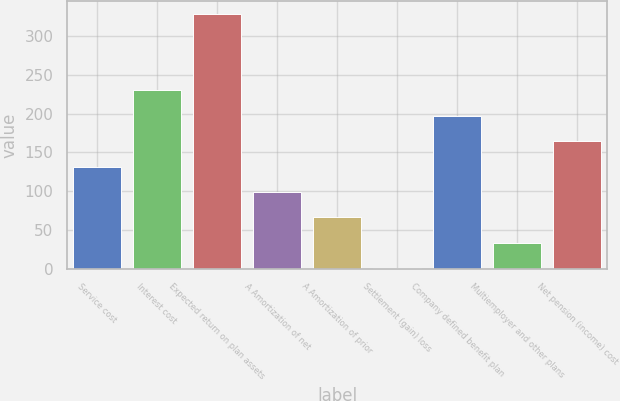<chart> <loc_0><loc_0><loc_500><loc_500><bar_chart><fcel>Service cost<fcel>Interest cost<fcel>Expected return on plan assets<fcel>A Amortization of net<fcel>A Amortization of prior<fcel>Settlement (gain) loss<fcel>Company defined benefit plan<fcel>Multiemployer and other plans<fcel>Net pension (income) cost<nl><fcel>131.66<fcel>230.03<fcel>328.4<fcel>98.87<fcel>66.08<fcel>0.5<fcel>197.24<fcel>33.29<fcel>164.45<nl></chart> 